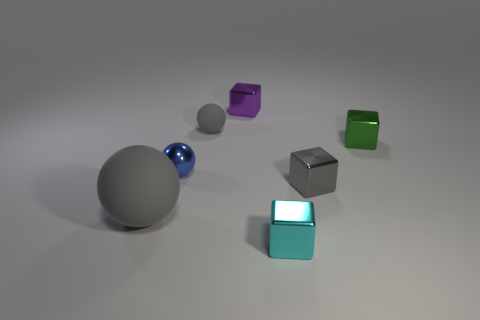Subtract all small rubber spheres. How many spheres are left? 2 Add 1 tiny purple balls. How many objects exist? 8 Subtract 1 blocks. How many blocks are left? 3 Subtract all blocks. How many objects are left? 3 Add 3 gray objects. How many gray objects exist? 6 Subtract all cyan cubes. How many cubes are left? 3 Subtract 1 purple cubes. How many objects are left? 6 Subtract all cyan balls. Subtract all purple blocks. How many balls are left? 3 Subtract all brown spheres. How many gray blocks are left? 1 Subtract all gray metallic things. Subtract all gray rubber balls. How many objects are left? 4 